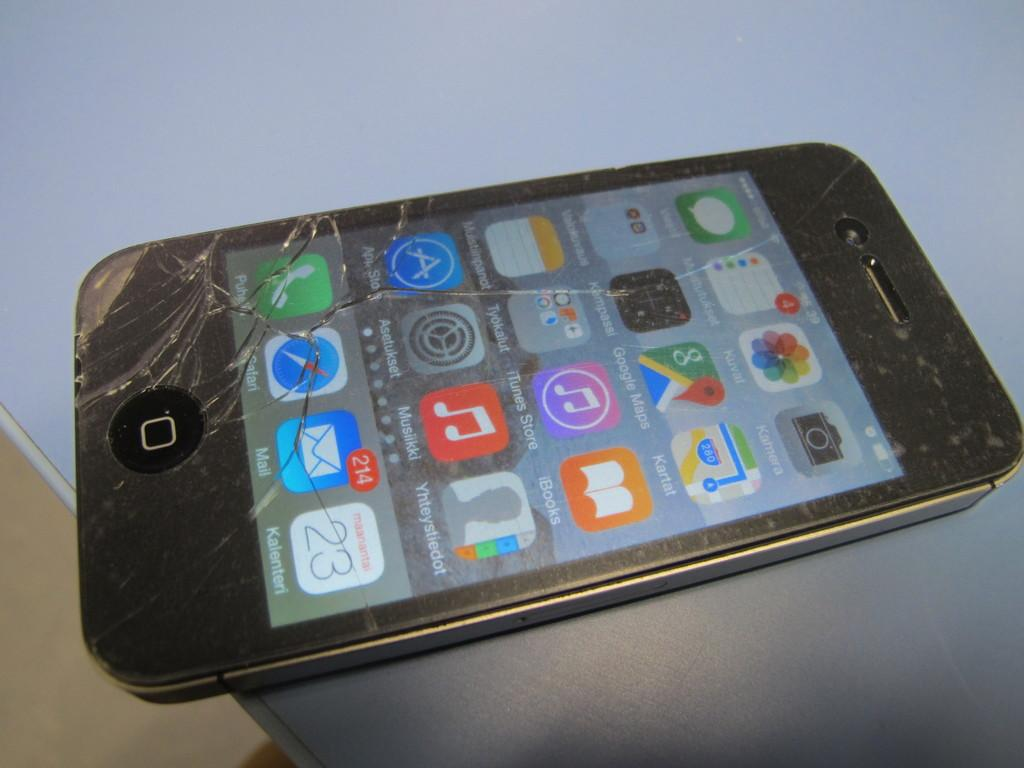<image>
Present a compact description of the photo's key features. An iphone with a cracked display showing 214 unread emails. 